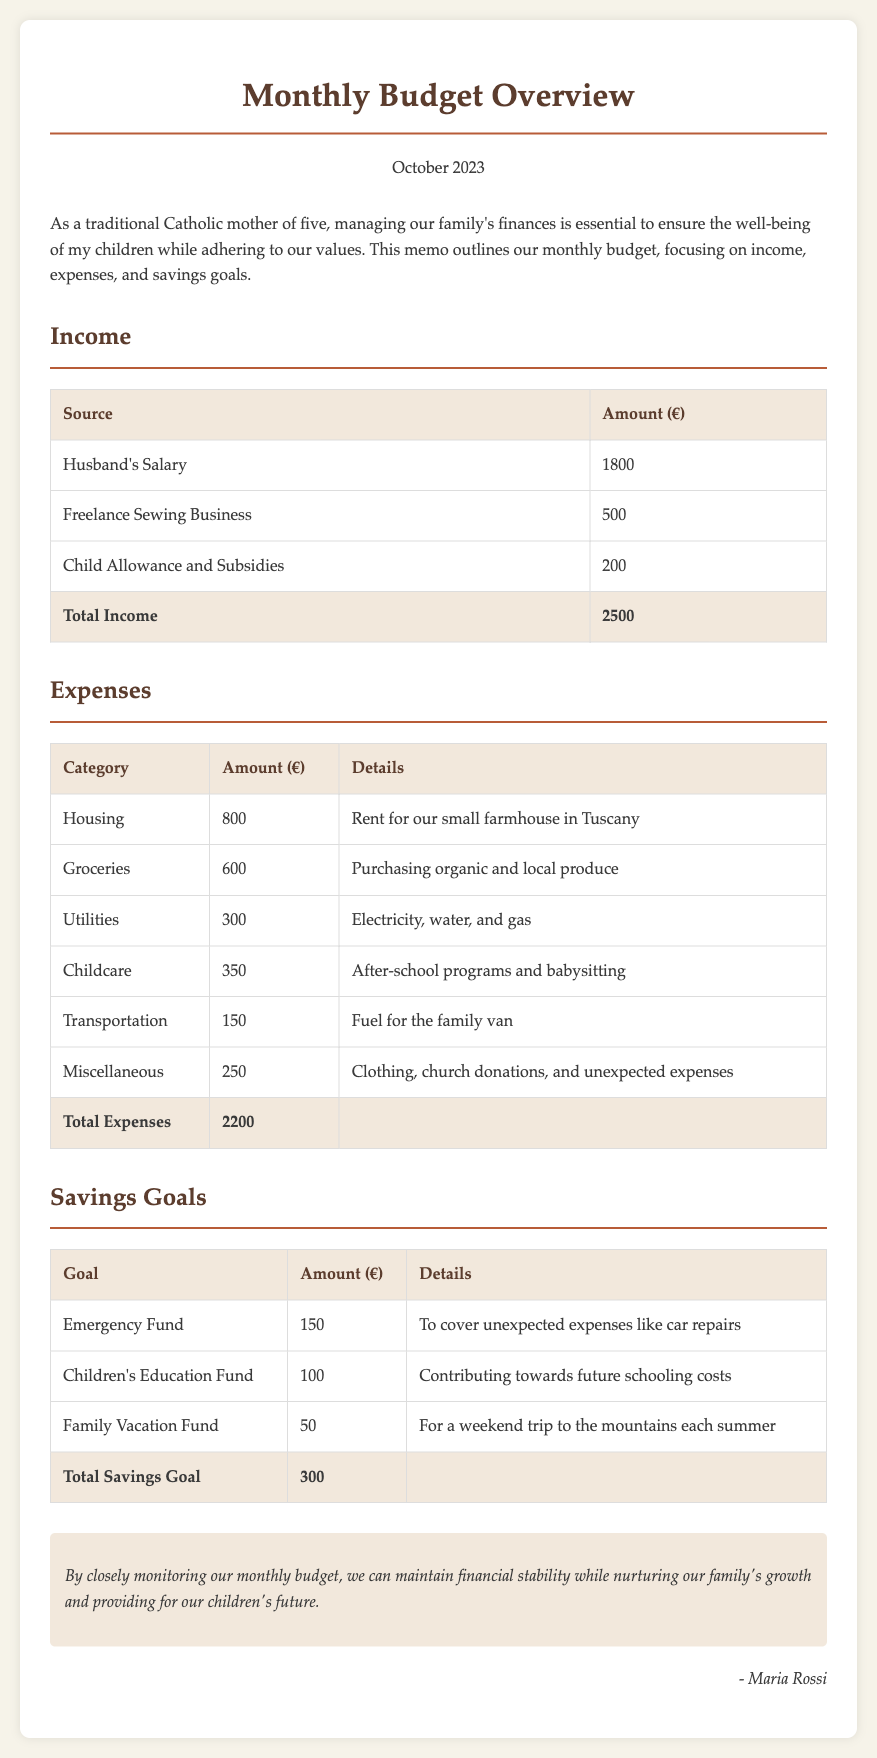What is the total income? The total income is the sum of all income sources listed in the document, which includes husband's salary, freelance business, and child allowance.
Answer: 2500 What is the amount spent on groceries? The amount spent on groceries is specifically mentioned in the expenses table under the groceries category.
Answer: 600 How much is allocated for the Emergency Fund? The amount allocated for the Emergency Fund is specified in the savings goals table under the corresponding goal.
Answer: 150 What is the total expense amount? The total expense amount is the sum of all expenses listed in the document.
Answer: 2200 What is the income source with the largest amount? The income source that has the largest amount is identified in the income section of the document.
Answer: Husband's Salary What is the amount set aside for Children's Education Fund? The amount set aside for the Children’s Education Fund is mentioned in the savings goals section.
Answer: 100 What is the total savings goal? The total savings goal is the sum of all savings goals listed in the document.
Answer: 300 What category has the lowest expense? The category with the lowest expense is indicated in the expenses breakdown.
Answer: Transportation What is the main purpose of this memo? The main purpose of the memo is described in the introduction section and relates to family finance management.
Answer: Monthly budget overview 